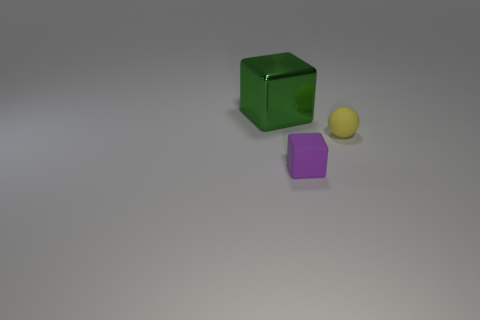There is a cube that is the same size as the yellow ball; what is its material?
Offer a very short reply. Rubber. What number of other objects are the same material as the big green cube?
Make the answer very short. 0. Is the number of big metallic blocks that are in front of the yellow matte thing the same as the number of large green cubes that are on the right side of the purple block?
Provide a succinct answer. Yes. What number of green objects are small cylinders or metal things?
Keep it short and to the point. 1. There is a metallic cube; does it have the same color as the rubber object to the left of the yellow rubber thing?
Offer a terse response. No. What number of other objects are there of the same color as the ball?
Ensure brevity in your answer.  0. Is the number of gray metal balls less than the number of green metallic objects?
Offer a very short reply. Yes. There is a cube on the right side of the cube that is behind the yellow matte ball; what number of big blocks are behind it?
Ensure brevity in your answer.  1. There is a object that is in front of the rubber sphere; how big is it?
Your response must be concise. Small. There is a green object that is behind the small yellow matte sphere; does it have the same shape as the small purple rubber thing?
Ensure brevity in your answer.  Yes. 